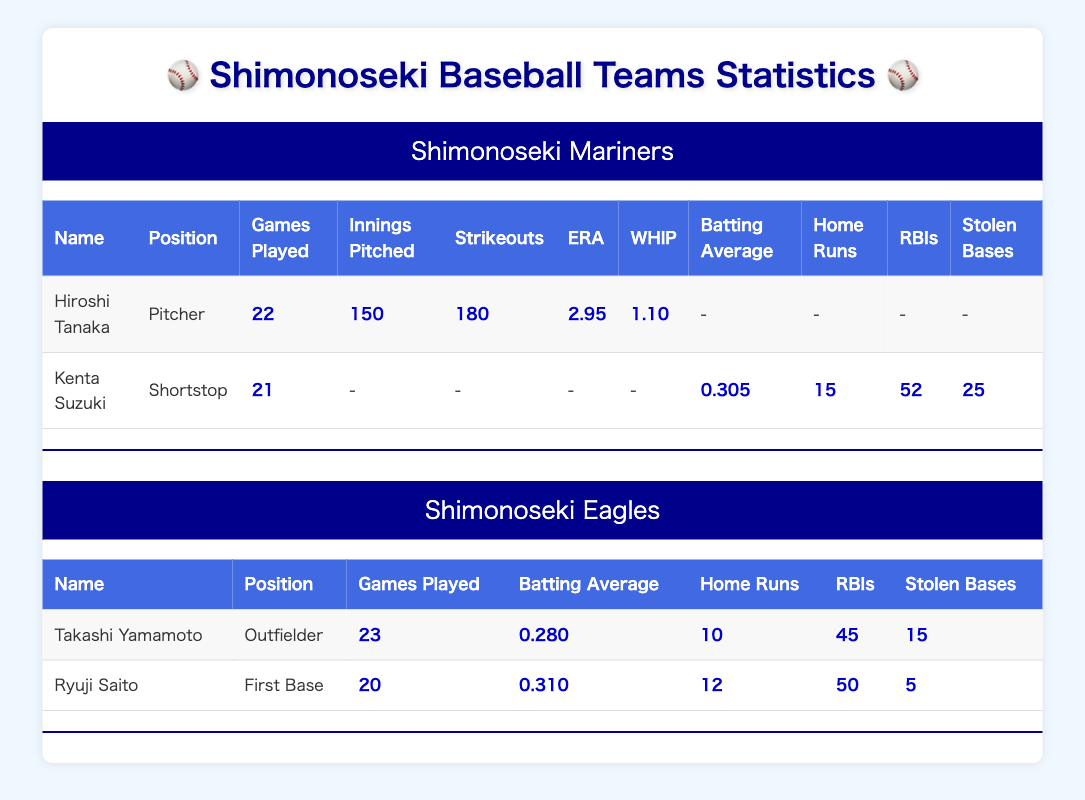What's the batting average of Kenta Suzuki? The table shows Kenta Suzuki as a player for the Shimonoseki Mariners, and his batting average is clearly listed as 0.305.
Answer: 0.305 Which player from the Shimonoseki Eagles has the highest number of home runs? In the list of home runs for players in the Eagles team, Takashi Yamamoto has 10 home runs and Ryuji Saito has 12. Hence, Ryuji Saito has the highest number.
Answer: Ryuji Saito Total strikeouts by Hiroshi Tanaka are how many? The table specifies that Hiroshi Tanaka made 180 strikeouts, which is noted directly in his player's data.
Answer: 180 Does Kenta Suzuki have more stolen bases than Ryuji Saito? Kenta Suzuki has 25 stolen bases, while Ryuji Saito only has 5, meaning Kenta Suzuki does have more stolen bases.
Answer: Yes What is the average batting average of all players from the Shimonoseki Mariners? For the Mariners, we have Kenta Suzuki with a batting average of 0.305 and Hiroshi Tanaka who does not have a batting average since he is a pitcher. To find the average, we only consider Kenta Suzuki: average = 0.305/1 = 0.305.
Answer: 0.305 Which team has more players who played at least 20 games? The Shimonoseki Mariners have Kenta Suzuki (21 games) and Hiroshi Tanaka (22 games), totaling 2 players, while the Eagles have Takashi Yamamoto (23 games) and Ryuji Saito (20 games)—also totaling 2 players. Both teams have the same number of players who played at least 20 games.
Answer: Both teams are equal What is the combined total of RBIs for players in the Shimonoseki Mariners? The RBIs for Kenta Suzuki are 52. Hiroshi Tanaka has no RBIs recorded, so to combine them: 52 RBIs (Kenta Suzuki) + 0 RBIs (Hiroshi Tanaka) = 52.
Answer: 52 Which player has the lowest WHIP value? The table shows that Hiroshi Tanaka has a WHIP of 1.10, and there are no WHIP stats available for the batters. As such, he has the lowest value.
Answer: Hiroshi Tanaka 